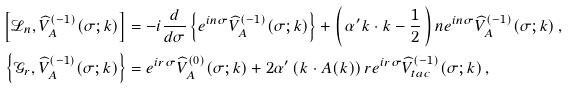<formula> <loc_0><loc_0><loc_500><loc_500>\left [ \mathcal { L } _ { n } , \widehat { V } ^ { ( - 1 ) } _ { A } ( \sigma ; k ) \right ] & = - i \frac { d } { d \sigma } \left \{ e ^ { i n \sigma } \widehat { V } _ { A } ^ { ( - 1 ) } ( \sigma ; k ) \right \} + \left ( \, \alpha ^ { \prime } k \cdot { k } - \frac { 1 } { 2 } \, \right ) n e ^ { i n \sigma } \widehat { V } _ { A } ^ { ( - 1 ) } ( \sigma ; k ) \, , \\ \left \{ \mathcal { G } _ { r } , \widehat { V } ^ { ( - 1 ) } _ { A } ( \sigma ; k ) \right \} & = e ^ { i r \sigma } \widehat { V } _ { A } ^ { ( 0 ) } ( \sigma ; k ) + 2 \alpha ^ { \prime } \left ( k \cdot { A } ( k ) \right ) r e ^ { i r \sigma } \widehat { V } _ { t a c } ^ { ( - 1 ) } ( \sigma ; k ) \, ,</formula> 